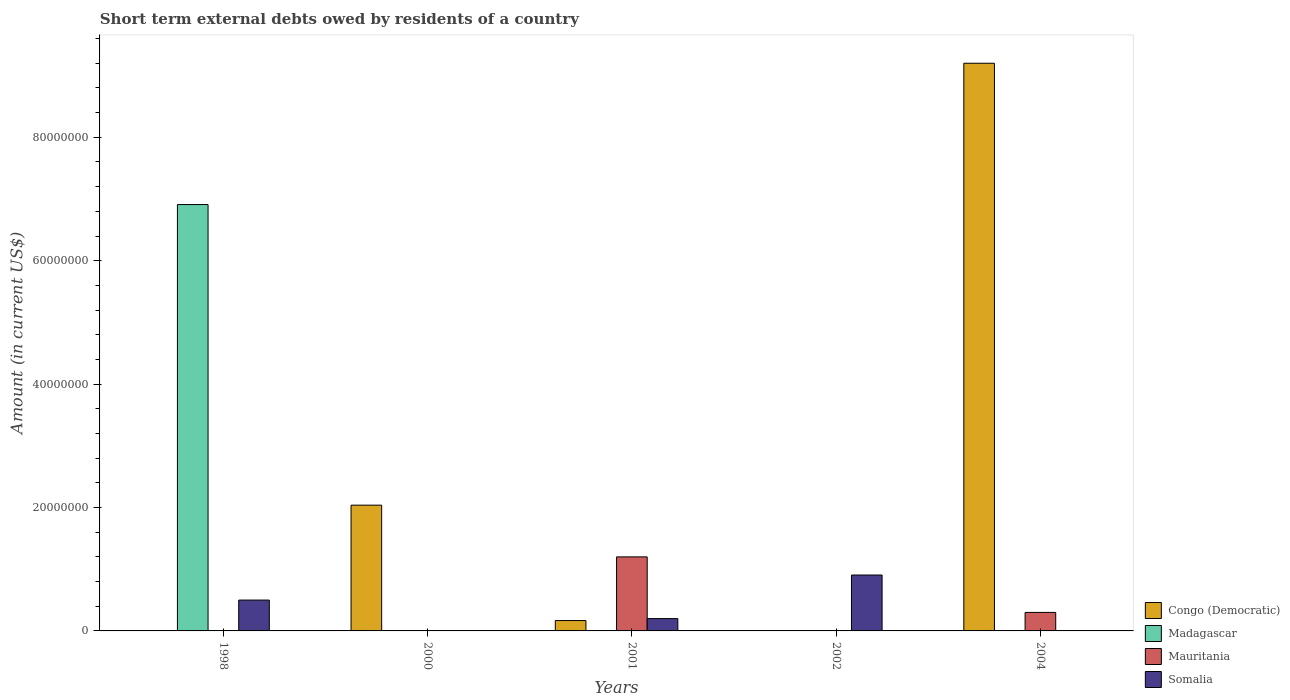How many different coloured bars are there?
Make the answer very short. 4. Are the number of bars per tick equal to the number of legend labels?
Keep it short and to the point. No. Are the number of bars on each tick of the X-axis equal?
Provide a succinct answer. No. How many bars are there on the 1st tick from the left?
Give a very brief answer. 2. What is the amount of short-term external debts owed by residents in Madagascar in 1998?
Your answer should be very brief. 6.91e+07. Across all years, what is the maximum amount of short-term external debts owed by residents in Congo (Democratic)?
Your response must be concise. 9.20e+07. Across all years, what is the minimum amount of short-term external debts owed by residents in Somalia?
Ensure brevity in your answer.  0. In which year was the amount of short-term external debts owed by residents in Congo (Democratic) maximum?
Provide a succinct answer. 2004. What is the total amount of short-term external debts owed by residents in Congo (Democratic) in the graph?
Keep it short and to the point. 1.14e+08. What is the difference between the amount of short-term external debts owed by residents in Mauritania in 2001 and that in 2004?
Ensure brevity in your answer.  9.00e+06. What is the difference between the amount of short-term external debts owed by residents in Madagascar in 2000 and the amount of short-term external debts owed by residents in Somalia in 2001?
Ensure brevity in your answer.  -2.00e+06. What is the average amount of short-term external debts owed by residents in Mauritania per year?
Make the answer very short. 3.00e+06. In the year 2004, what is the difference between the amount of short-term external debts owed by residents in Congo (Democratic) and amount of short-term external debts owed by residents in Mauritania?
Provide a succinct answer. 8.90e+07. In how many years, is the amount of short-term external debts owed by residents in Madagascar greater than 56000000 US$?
Offer a terse response. 1. What is the difference between the highest and the second highest amount of short-term external debts owed by residents in Somalia?
Keep it short and to the point. 4.06e+06. What is the difference between the highest and the lowest amount of short-term external debts owed by residents in Somalia?
Offer a very short reply. 9.06e+06. How many bars are there?
Keep it short and to the point. 9. Does the graph contain any zero values?
Make the answer very short. Yes. How many legend labels are there?
Provide a short and direct response. 4. What is the title of the graph?
Your response must be concise. Short term external debts owed by residents of a country. What is the label or title of the X-axis?
Offer a terse response. Years. What is the label or title of the Y-axis?
Give a very brief answer. Amount (in current US$). What is the Amount (in current US$) of Congo (Democratic) in 1998?
Your answer should be very brief. 0. What is the Amount (in current US$) in Madagascar in 1998?
Offer a terse response. 6.91e+07. What is the Amount (in current US$) in Congo (Democratic) in 2000?
Your response must be concise. 2.04e+07. What is the Amount (in current US$) in Congo (Democratic) in 2001?
Ensure brevity in your answer.  1.68e+06. What is the Amount (in current US$) in Madagascar in 2001?
Offer a very short reply. 0. What is the Amount (in current US$) of Mauritania in 2001?
Offer a very short reply. 1.20e+07. What is the Amount (in current US$) in Somalia in 2001?
Your response must be concise. 2.00e+06. What is the Amount (in current US$) in Congo (Democratic) in 2002?
Give a very brief answer. 0. What is the Amount (in current US$) of Mauritania in 2002?
Your answer should be compact. 0. What is the Amount (in current US$) in Somalia in 2002?
Keep it short and to the point. 9.06e+06. What is the Amount (in current US$) of Congo (Democratic) in 2004?
Make the answer very short. 9.20e+07. What is the Amount (in current US$) in Madagascar in 2004?
Keep it short and to the point. 0. What is the Amount (in current US$) in Mauritania in 2004?
Offer a very short reply. 3.00e+06. What is the Amount (in current US$) of Somalia in 2004?
Your answer should be compact. 0. Across all years, what is the maximum Amount (in current US$) of Congo (Democratic)?
Make the answer very short. 9.20e+07. Across all years, what is the maximum Amount (in current US$) in Madagascar?
Provide a succinct answer. 6.91e+07. Across all years, what is the maximum Amount (in current US$) in Somalia?
Offer a very short reply. 9.06e+06. Across all years, what is the minimum Amount (in current US$) in Congo (Democratic)?
Provide a succinct answer. 0. What is the total Amount (in current US$) of Congo (Democratic) in the graph?
Keep it short and to the point. 1.14e+08. What is the total Amount (in current US$) of Madagascar in the graph?
Offer a very short reply. 6.91e+07. What is the total Amount (in current US$) in Mauritania in the graph?
Your answer should be compact. 1.50e+07. What is the total Amount (in current US$) in Somalia in the graph?
Keep it short and to the point. 1.61e+07. What is the difference between the Amount (in current US$) in Somalia in 1998 and that in 2001?
Offer a very short reply. 3.00e+06. What is the difference between the Amount (in current US$) in Somalia in 1998 and that in 2002?
Offer a terse response. -4.06e+06. What is the difference between the Amount (in current US$) of Congo (Democratic) in 2000 and that in 2001?
Your response must be concise. 1.87e+07. What is the difference between the Amount (in current US$) of Congo (Democratic) in 2000 and that in 2004?
Your answer should be very brief. -7.16e+07. What is the difference between the Amount (in current US$) in Somalia in 2001 and that in 2002?
Your answer should be compact. -7.06e+06. What is the difference between the Amount (in current US$) of Congo (Democratic) in 2001 and that in 2004?
Keep it short and to the point. -9.03e+07. What is the difference between the Amount (in current US$) in Mauritania in 2001 and that in 2004?
Your answer should be compact. 9.00e+06. What is the difference between the Amount (in current US$) in Madagascar in 1998 and the Amount (in current US$) in Mauritania in 2001?
Your answer should be compact. 5.71e+07. What is the difference between the Amount (in current US$) in Madagascar in 1998 and the Amount (in current US$) in Somalia in 2001?
Make the answer very short. 6.71e+07. What is the difference between the Amount (in current US$) in Madagascar in 1998 and the Amount (in current US$) in Somalia in 2002?
Provide a succinct answer. 6.00e+07. What is the difference between the Amount (in current US$) in Madagascar in 1998 and the Amount (in current US$) in Mauritania in 2004?
Keep it short and to the point. 6.61e+07. What is the difference between the Amount (in current US$) in Congo (Democratic) in 2000 and the Amount (in current US$) in Mauritania in 2001?
Your answer should be very brief. 8.38e+06. What is the difference between the Amount (in current US$) in Congo (Democratic) in 2000 and the Amount (in current US$) in Somalia in 2001?
Provide a succinct answer. 1.84e+07. What is the difference between the Amount (in current US$) of Congo (Democratic) in 2000 and the Amount (in current US$) of Somalia in 2002?
Your answer should be compact. 1.13e+07. What is the difference between the Amount (in current US$) of Congo (Democratic) in 2000 and the Amount (in current US$) of Mauritania in 2004?
Offer a very short reply. 1.74e+07. What is the difference between the Amount (in current US$) in Congo (Democratic) in 2001 and the Amount (in current US$) in Somalia in 2002?
Your response must be concise. -7.38e+06. What is the difference between the Amount (in current US$) in Mauritania in 2001 and the Amount (in current US$) in Somalia in 2002?
Provide a succinct answer. 2.94e+06. What is the difference between the Amount (in current US$) of Congo (Democratic) in 2001 and the Amount (in current US$) of Mauritania in 2004?
Give a very brief answer. -1.32e+06. What is the average Amount (in current US$) in Congo (Democratic) per year?
Your response must be concise. 2.28e+07. What is the average Amount (in current US$) of Madagascar per year?
Offer a very short reply. 1.38e+07. What is the average Amount (in current US$) of Mauritania per year?
Ensure brevity in your answer.  3.00e+06. What is the average Amount (in current US$) of Somalia per year?
Your answer should be very brief. 3.21e+06. In the year 1998, what is the difference between the Amount (in current US$) in Madagascar and Amount (in current US$) in Somalia?
Offer a very short reply. 6.41e+07. In the year 2001, what is the difference between the Amount (in current US$) in Congo (Democratic) and Amount (in current US$) in Mauritania?
Provide a succinct answer. -1.03e+07. In the year 2001, what is the difference between the Amount (in current US$) in Congo (Democratic) and Amount (in current US$) in Somalia?
Provide a short and direct response. -3.20e+05. In the year 2004, what is the difference between the Amount (in current US$) in Congo (Democratic) and Amount (in current US$) in Mauritania?
Keep it short and to the point. 8.90e+07. What is the ratio of the Amount (in current US$) of Somalia in 1998 to that in 2002?
Ensure brevity in your answer.  0.55. What is the ratio of the Amount (in current US$) in Congo (Democratic) in 2000 to that in 2001?
Make the answer very short. 12.13. What is the ratio of the Amount (in current US$) of Congo (Democratic) in 2000 to that in 2004?
Your answer should be compact. 0.22. What is the ratio of the Amount (in current US$) of Somalia in 2001 to that in 2002?
Make the answer very short. 0.22. What is the ratio of the Amount (in current US$) in Congo (Democratic) in 2001 to that in 2004?
Keep it short and to the point. 0.02. What is the ratio of the Amount (in current US$) of Mauritania in 2001 to that in 2004?
Make the answer very short. 4. What is the difference between the highest and the second highest Amount (in current US$) of Congo (Democratic)?
Your answer should be very brief. 7.16e+07. What is the difference between the highest and the second highest Amount (in current US$) in Somalia?
Keep it short and to the point. 4.06e+06. What is the difference between the highest and the lowest Amount (in current US$) in Congo (Democratic)?
Your answer should be very brief. 9.20e+07. What is the difference between the highest and the lowest Amount (in current US$) in Madagascar?
Ensure brevity in your answer.  6.91e+07. What is the difference between the highest and the lowest Amount (in current US$) in Mauritania?
Your answer should be compact. 1.20e+07. What is the difference between the highest and the lowest Amount (in current US$) in Somalia?
Give a very brief answer. 9.06e+06. 